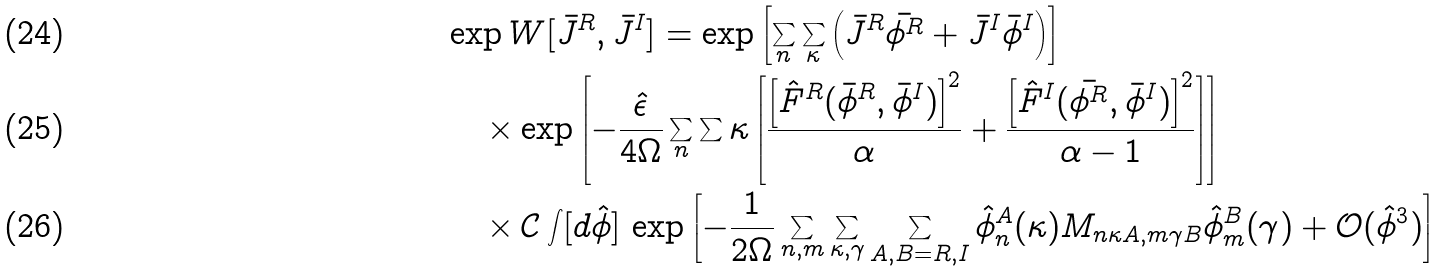<formula> <loc_0><loc_0><loc_500><loc_500>& \exp { W [ \bar { J } ^ { R } , \bar { J } ^ { I } ] } = \exp { \left [ \sum _ { n } \sum _ { \kappa } \left ( \bar { J } ^ { R } \bar { \phi ^ { R } } + \bar { J } ^ { I } \bar { \phi } ^ { I } \right ) \right ] } \\ & \quad \times \exp { \left [ - \frac { \hat { \epsilon } } { 4 \Omega } \sum _ { n } \sum { \kappa } \left [ \frac { \left [ \hat { F } ^ { R } ( \bar { \phi } ^ { R } , \bar { \phi } ^ { I } ) \right ] ^ { 2 } } { \alpha } + \frac { \left [ \hat { F } ^ { I } ( \bar { \phi ^ { R } } , \bar { \phi } ^ { I } ) \right ] ^ { 2 } } { \alpha - 1 } \right ] \right ] } \\ & \quad \times \mathcal { C } \int [ d \hat { \phi } ] \, \exp \left [ - \frac { 1 } { 2 \Omega } \sum _ { n , m } \sum _ { \kappa , \gamma } \sum _ { A , B = R , I } \hat { \phi } _ { n } ^ { A } ( \kappa ) M _ { n \kappa A , m \gamma B } \hat { \phi } _ { m } ^ { B } ( \gamma ) + \mathcal { O } ( \hat { \phi } ^ { 3 } ) \right ]</formula> 